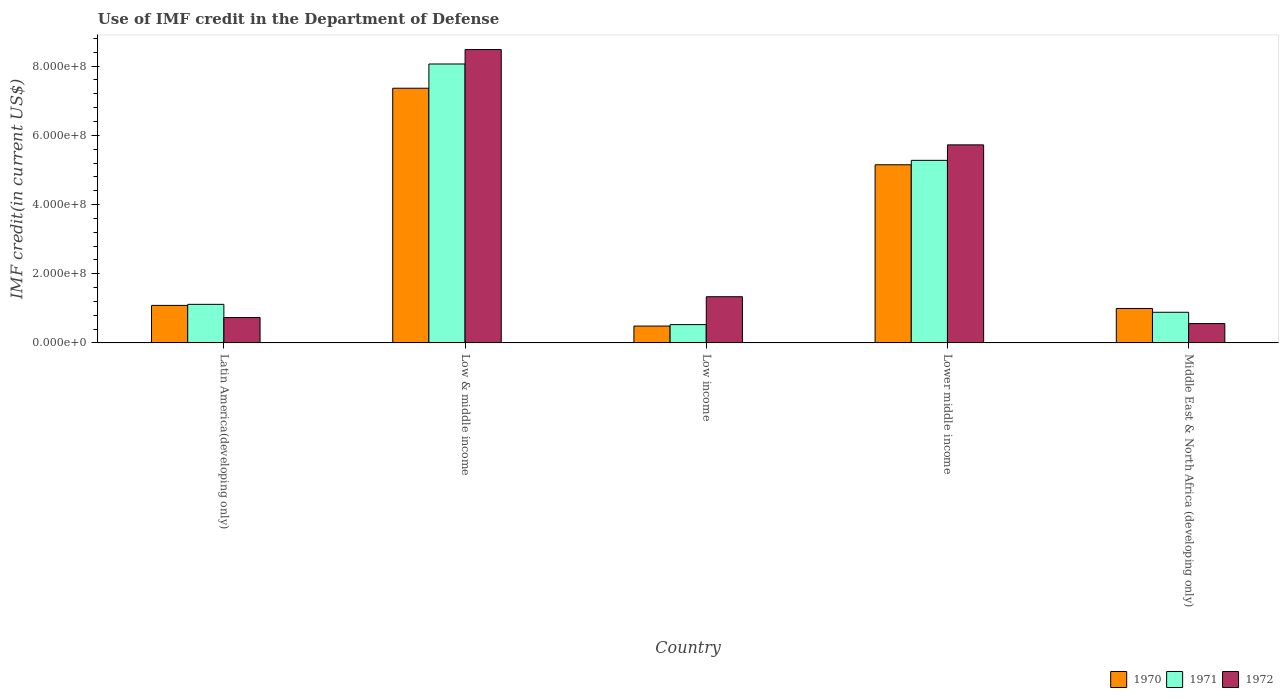How many different coloured bars are there?
Give a very brief answer. 3. How many groups of bars are there?
Provide a succinct answer. 5. Are the number of bars per tick equal to the number of legend labels?
Ensure brevity in your answer.  Yes. How many bars are there on the 4th tick from the right?
Offer a very short reply. 3. In how many cases, is the number of bars for a given country not equal to the number of legend labels?
Your answer should be very brief. 0. What is the IMF credit in the Department of Defense in 1971 in Latin America(developing only)?
Keep it short and to the point. 1.12e+08. Across all countries, what is the maximum IMF credit in the Department of Defense in 1970?
Give a very brief answer. 7.36e+08. Across all countries, what is the minimum IMF credit in the Department of Defense in 1972?
Your answer should be compact. 5.59e+07. In which country was the IMF credit in the Department of Defense in 1972 minimum?
Provide a short and direct response. Middle East & North Africa (developing only). What is the total IMF credit in the Department of Defense in 1970 in the graph?
Keep it short and to the point. 1.51e+09. What is the difference between the IMF credit in the Department of Defense in 1972 in Latin America(developing only) and that in Low income?
Offer a very short reply. -6.01e+07. What is the difference between the IMF credit in the Department of Defense in 1971 in Latin America(developing only) and the IMF credit in the Department of Defense in 1972 in Lower middle income?
Provide a short and direct response. -4.61e+08. What is the average IMF credit in the Department of Defense in 1970 per country?
Provide a short and direct response. 3.02e+08. What is the difference between the IMF credit in the Department of Defense of/in 1972 and IMF credit in the Department of Defense of/in 1971 in Middle East & North Africa (developing only)?
Provide a succinct answer. -3.27e+07. What is the ratio of the IMF credit in the Department of Defense in 1972 in Lower middle income to that in Middle East & North Africa (developing only)?
Give a very brief answer. 10.24. What is the difference between the highest and the second highest IMF credit in the Department of Defense in 1971?
Give a very brief answer. 2.79e+08. What is the difference between the highest and the lowest IMF credit in the Department of Defense in 1970?
Make the answer very short. 6.87e+08. What does the 3rd bar from the left in Middle East & North Africa (developing only) represents?
Your response must be concise. 1972. What does the 1st bar from the right in Lower middle income represents?
Provide a short and direct response. 1972. Is it the case that in every country, the sum of the IMF credit in the Department of Defense in 1972 and IMF credit in the Department of Defense in 1970 is greater than the IMF credit in the Department of Defense in 1971?
Your answer should be compact. Yes. How many countries are there in the graph?
Give a very brief answer. 5. Does the graph contain any zero values?
Provide a succinct answer. No. Does the graph contain grids?
Give a very brief answer. No. How many legend labels are there?
Provide a short and direct response. 3. What is the title of the graph?
Your answer should be very brief. Use of IMF credit in the Department of Defense. Does "1998" appear as one of the legend labels in the graph?
Your response must be concise. No. What is the label or title of the Y-axis?
Your response must be concise. IMF credit(in current US$). What is the IMF credit(in current US$) of 1970 in Latin America(developing only)?
Keep it short and to the point. 1.09e+08. What is the IMF credit(in current US$) in 1971 in Latin America(developing only)?
Provide a succinct answer. 1.12e+08. What is the IMF credit(in current US$) of 1972 in Latin America(developing only)?
Make the answer very short. 7.34e+07. What is the IMF credit(in current US$) of 1970 in Low & middle income?
Offer a very short reply. 7.36e+08. What is the IMF credit(in current US$) in 1971 in Low & middle income?
Offer a very short reply. 8.06e+08. What is the IMF credit(in current US$) in 1972 in Low & middle income?
Make the answer very short. 8.48e+08. What is the IMF credit(in current US$) of 1970 in Low income?
Your answer should be very brief. 4.88e+07. What is the IMF credit(in current US$) in 1971 in Low income?
Make the answer very short. 5.30e+07. What is the IMF credit(in current US$) in 1972 in Low income?
Your answer should be compact. 1.34e+08. What is the IMF credit(in current US$) of 1970 in Lower middle income?
Your answer should be very brief. 5.15e+08. What is the IMF credit(in current US$) in 1971 in Lower middle income?
Offer a terse response. 5.28e+08. What is the IMF credit(in current US$) in 1972 in Lower middle income?
Your answer should be very brief. 5.73e+08. What is the IMF credit(in current US$) in 1970 in Middle East & North Africa (developing only)?
Your answer should be compact. 9.96e+07. What is the IMF credit(in current US$) in 1971 in Middle East & North Africa (developing only)?
Keep it short and to the point. 8.86e+07. What is the IMF credit(in current US$) in 1972 in Middle East & North Africa (developing only)?
Offer a very short reply. 5.59e+07. Across all countries, what is the maximum IMF credit(in current US$) of 1970?
Give a very brief answer. 7.36e+08. Across all countries, what is the maximum IMF credit(in current US$) in 1971?
Your answer should be compact. 8.06e+08. Across all countries, what is the maximum IMF credit(in current US$) of 1972?
Your answer should be compact. 8.48e+08. Across all countries, what is the minimum IMF credit(in current US$) in 1970?
Ensure brevity in your answer.  4.88e+07. Across all countries, what is the minimum IMF credit(in current US$) in 1971?
Your answer should be compact. 5.30e+07. Across all countries, what is the minimum IMF credit(in current US$) in 1972?
Make the answer very short. 5.59e+07. What is the total IMF credit(in current US$) of 1970 in the graph?
Offer a very short reply. 1.51e+09. What is the total IMF credit(in current US$) in 1971 in the graph?
Your answer should be compact. 1.59e+09. What is the total IMF credit(in current US$) in 1972 in the graph?
Offer a terse response. 1.68e+09. What is the difference between the IMF credit(in current US$) in 1970 in Latin America(developing only) and that in Low & middle income?
Your answer should be very brief. -6.28e+08. What is the difference between the IMF credit(in current US$) in 1971 in Latin America(developing only) and that in Low & middle income?
Keep it short and to the point. -6.95e+08. What is the difference between the IMF credit(in current US$) in 1972 in Latin America(developing only) and that in Low & middle income?
Give a very brief answer. -7.75e+08. What is the difference between the IMF credit(in current US$) in 1970 in Latin America(developing only) and that in Low income?
Your answer should be very brief. 5.97e+07. What is the difference between the IMF credit(in current US$) of 1971 in Latin America(developing only) and that in Low income?
Make the answer very short. 5.85e+07. What is the difference between the IMF credit(in current US$) of 1972 in Latin America(developing only) and that in Low income?
Provide a short and direct response. -6.01e+07. What is the difference between the IMF credit(in current US$) of 1970 in Latin America(developing only) and that in Lower middle income?
Make the answer very short. -4.06e+08. What is the difference between the IMF credit(in current US$) in 1971 in Latin America(developing only) and that in Lower middle income?
Make the answer very short. -4.16e+08. What is the difference between the IMF credit(in current US$) in 1972 in Latin America(developing only) and that in Lower middle income?
Provide a short and direct response. -4.99e+08. What is the difference between the IMF credit(in current US$) in 1970 in Latin America(developing only) and that in Middle East & North Africa (developing only)?
Offer a terse response. 8.90e+06. What is the difference between the IMF credit(in current US$) of 1971 in Latin America(developing only) and that in Middle East & North Africa (developing only)?
Offer a very short reply. 2.29e+07. What is the difference between the IMF credit(in current US$) of 1972 in Latin America(developing only) and that in Middle East & North Africa (developing only)?
Make the answer very short. 1.75e+07. What is the difference between the IMF credit(in current US$) of 1970 in Low & middle income and that in Low income?
Your answer should be very brief. 6.87e+08. What is the difference between the IMF credit(in current US$) of 1971 in Low & middle income and that in Low income?
Give a very brief answer. 7.53e+08. What is the difference between the IMF credit(in current US$) in 1972 in Low & middle income and that in Low income?
Keep it short and to the point. 7.14e+08. What is the difference between the IMF credit(in current US$) of 1970 in Low & middle income and that in Lower middle income?
Ensure brevity in your answer.  2.21e+08. What is the difference between the IMF credit(in current US$) in 1971 in Low & middle income and that in Lower middle income?
Keep it short and to the point. 2.79e+08. What is the difference between the IMF credit(in current US$) in 1972 in Low & middle income and that in Lower middle income?
Provide a succinct answer. 2.76e+08. What is the difference between the IMF credit(in current US$) of 1970 in Low & middle income and that in Middle East & North Africa (developing only)?
Provide a short and direct response. 6.37e+08. What is the difference between the IMF credit(in current US$) in 1971 in Low & middle income and that in Middle East & North Africa (developing only)?
Make the answer very short. 7.18e+08. What is the difference between the IMF credit(in current US$) in 1972 in Low & middle income and that in Middle East & North Africa (developing only)?
Provide a short and direct response. 7.92e+08. What is the difference between the IMF credit(in current US$) of 1970 in Low income and that in Lower middle income?
Make the answer very short. -4.66e+08. What is the difference between the IMF credit(in current US$) of 1971 in Low income and that in Lower middle income?
Offer a very short reply. -4.75e+08. What is the difference between the IMF credit(in current US$) of 1972 in Low income and that in Lower middle income?
Your response must be concise. -4.39e+08. What is the difference between the IMF credit(in current US$) of 1970 in Low income and that in Middle East & North Africa (developing only)?
Offer a terse response. -5.08e+07. What is the difference between the IMF credit(in current US$) of 1971 in Low income and that in Middle East & North Africa (developing only)?
Ensure brevity in your answer.  -3.56e+07. What is the difference between the IMF credit(in current US$) of 1972 in Low income and that in Middle East & North Africa (developing only)?
Give a very brief answer. 7.76e+07. What is the difference between the IMF credit(in current US$) of 1970 in Lower middle income and that in Middle East & North Africa (developing only)?
Your answer should be compact. 4.15e+08. What is the difference between the IMF credit(in current US$) of 1971 in Lower middle income and that in Middle East & North Africa (developing only)?
Your response must be concise. 4.39e+08. What is the difference between the IMF credit(in current US$) of 1972 in Lower middle income and that in Middle East & North Africa (developing only)?
Your answer should be compact. 5.17e+08. What is the difference between the IMF credit(in current US$) in 1970 in Latin America(developing only) and the IMF credit(in current US$) in 1971 in Low & middle income?
Give a very brief answer. -6.98e+08. What is the difference between the IMF credit(in current US$) in 1970 in Latin America(developing only) and the IMF credit(in current US$) in 1972 in Low & middle income?
Your answer should be very brief. -7.40e+08. What is the difference between the IMF credit(in current US$) in 1971 in Latin America(developing only) and the IMF credit(in current US$) in 1972 in Low & middle income?
Your answer should be very brief. -7.37e+08. What is the difference between the IMF credit(in current US$) of 1970 in Latin America(developing only) and the IMF credit(in current US$) of 1971 in Low income?
Keep it short and to the point. 5.55e+07. What is the difference between the IMF credit(in current US$) in 1970 in Latin America(developing only) and the IMF credit(in current US$) in 1972 in Low income?
Give a very brief answer. -2.50e+07. What is the difference between the IMF credit(in current US$) of 1971 in Latin America(developing only) and the IMF credit(in current US$) of 1972 in Low income?
Provide a succinct answer. -2.20e+07. What is the difference between the IMF credit(in current US$) in 1970 in Latin America(developing only) and the IMF credit(in current US$) in 1971 in Lower middle income?
Provide a short and direct response. -4.19e+08. What is the difference between the IMF credit(in current US$) in 1970 in Latin America(developing only) and the IMF credit(in current US$) in 1972 in Lower middle income?
Give a very brief answer. -4.64e+08. What is the difference between the IMF credit(in current US$) in 1971 in Latin America(developing only) and the IMF credit(in current US$) in 1972 in Lower middle income?
Your response must be concise. -4.61e+08. What is the difference between the IMF credit(in current US$) in 1970 in Latin America(developing only) and the IMF credit(in current US$) in 1971 in Middle East & North Africa (developing only)?
Your answer should be compact. 1.99e+07. What is the difference between the IMF credit(in current US$) of 1970 in Latin America(developing only) and the IMF credit(in current US$) of 1972 in Middle East & North Africa (developing only)?
Keep it short and to the point. 5.26e+07. What is the difference between the IMF credit(in current US$) of 1971 in Latin America(developing only) and the IMF credit(in current US$) of 1972 in Middle East & North Africa (developing only)?
Provide a short and direct response. 5.56e+07. What is the difference between the IMF credit(in current US$) of 1970 in Low & middle income and the IMF credit(in current US$) of 1971 in Low income?
Keep it short and to the point. 6.83e+08. What is the difference between the IMF credit(in current US$) in 1970 in Low & middle income and the IMF credit(in current US$) in 1972 in Low income?
Provide a succinct answer. 6.03e+08. What is the difference between the IMF credit(in current US$) in 1971 in Low & middle income and the IMF credit(in current US$) in 1972 in Low income?
Offer a very short reply. 6.73e+08. What is the difference between the IMF credit(in current US$) in 1970 in Low & middle income and the IMF credit(in current US$) in 1971 in Lower middle income?
Provide a short and direct response. 2.08e+08. What is the difference between the IMF credit(in current US$) of 1970 in Low & middle income and the IMF credit(in current US$) of 1972 in Lower middle income?
Give a very brief answer. 1.64e+08. What is the difference between the IMF credit(in current US$) in 1971 in Low & middle income and the IMF credit(in current US$) in 1972 in Lower middle income?
Offer a very short reply. 2.34e+08. What is the difference between the IMF credit(in current US$) of 1970 in Low & middle income and the IMF credit(in current US$) of 1971 in Middle East & North Africa (developing only)?
Your answer should be very brief. 6.48e+08. What is the difference between the IMF credit(in current US$) in 1970 in Low & middle income and the IMF credit(in current US$) in 1972 in Middle East & North Africa (developing only)?
Provide a succinct answer. 6.80e+08. What is the difference between the IMF credit(in current US$) in 1971 in Low & middle income and the IMF credit(in current US$) in 1972 in Middle East & North Africa (developing only)?
Your answer should be compact. 7.50e+08. What is the difference between the IMF credit(in current US$) of 1970 in Low income and the IMF credit(in current US$) of 1971 in Lower middle income?
Ensure brevity in your answer.  -4.79e+08. What is the difference between the IMF credit(in current US$) in 1970 in Low income and the IMF credit(in current US$) in 1972 in Lower middle income?
Offer a very short reply. -5.24e+08. What is the difference between the IMF credit(in current US$) in 1971 in Low income and the IMF credit(in current US$) in 1972 in Lower middle income?
Make the answer very short. -5.20e+08. What is the difference between the IMF credit(in current US$) in 1970 in Low income and the IMF credit(in current US$) in 1971 in Middle East & North Africa (developing only)?
Your answer should be compact. -3.98e+07. What is the difference between the IMF credit(in current US$) in 1970 in Low income and the IMF credit(in current US$) in 1972 in Middle East & North Africa (developing only)?
Ensure brevity in your answer.  -7.12e+06. What is the difference between the IMF credit(in current US$) of 1971 in Low income and the IMF credit(in current US$) of 1972 in Middle East & North Africa (developing only)?
Make the answer very short. -2.90e+06. What is the difference between the IMF credit(in current US$) of 1970 in Lower middle income and the IMF credit(in current US$) of 1971 in Middle East & North Africa (developing only)?
Your answer should be compact. 4.26e+08. What is the difference between the IMF credit(in current US$) in 1970 in Lower middle income and the IMF credit(in current US$) in 1972 in Middle East & North Africa (developing only)?
Offer a terse response. 4.59e+08. What is the difference between the IMF credit(in current US$) in 1971 in Lower middle income and the IMF credit(in current US$) in 1972 in Middle East & North Africa (developing only)?
Provide a succinct answer. 4.72e+08. What is the average IMF credit(in current US$) of 1970 per country?
Keep it short and to the point. 3.02e+08. What is the average IMF credit(in current US$) of 1971 per country?
Make the answer very short. 3.17e+08. What is the average IMF credit(in current US$) in 1972 per country?
Your answer should be compact. 3.37e+08. What is the difference between the IMF credit(in current US$) of 1970 and IMF credit(in current US$) of 1971 in Latin America(developing only)?
Offer a terse response. -3.01e+06. What is the difference between the IMF credit(in current US$) in 1970 and IMF credit(in current US$) in 1972 in Latin America(developing only)?
Provide a short and direct response. 3.51e+07. What is the difference between the IMF credit(in current US$) in 1971 and IMF credit(in current US$) in 1972 in Latin America(developing only)?
Your answer should be compact. 3.81e+07. What is the difference between the IMF credit(in current US$) of 1970 and IMF credit(in current US$) of 1971 in Low & middle income?
Provide a succinct answer. -7.00e+07. What is the difference between the IMF credit(in current US$) of 1970 and IMF credit(in current US$) of 1972 in Low & middle income?
Offer a terse response. -1.12e+08. What is the difference between the IMF credit(in current US$) of 1971 and IMF credit(in current US$) of 1972 in Low & middle income?
Offer a terse response. -4.18e+07. What is the difference between the IMF credit(in current US$) of 1970 and IMF credit(in current US$) of 1971 in Low income?
Keep it short and to the point. -4.21e+06. What is the difference between the IMF credit(in current US$) of 1970 and IMF credit(in current US$) of 1972 in Low income?
Your answer should be compact. -8.47e+07. What is the difference between the IMF credit(in current US$) in 1971 and IMF credit(in current US$) in 1972 in Low income?
Make the answer very short. -8.05e+07. What is the difference between the IMF credit(in current US$) in 1970 and IMF credit(in current US$) in 1971 in Lower middle income?
Provide a short and direct response. -1.28e+07. What is the difference between the IMF credit(in current US$) of 1970 and IMF credit(in current US$) of 1972 in Lower middle income?
Ensure brevity in your answer.  -5.76e+07. What is the difference between the IMF credit(in current US$) of 1971 and IMF credit(in current US$) of 1972 in Lower middle income?
Offer a terse response. -4.48e+07. What is the difference between the IMF credit(in current US$) in 1970 and IMF credit(in current US$) in 1971 in Middle East & North Africa (developing only)?
Provide a succinct answer. 1.10e+07. What is the difference between the IMF credit(in current US$) in 1970 and IMF credit(in current US$) in 1972 in Middle East & North Africa (developing only)?
Give a very brief answer. 4.37e+07. What is the difference between the IMF credit(in current US$) in 1971 and IMF credit(in current US$) in 1972 in Middle East & North Africa (developing only)?
Your answer should be compact. 3.27e+07. What is the ratio of the IMF credit(in current US$) in 1970 in Latin America(developing only) to that in Low & middle income?
Your answer should be compact. 0.15. What is the ratio of the IMF credit(in current US$) of 1971 in Latin America(developing only) to that in Low & middle income?
Provide a short and direct response. 0.14. What is the ratio of the IMF credit(in current US$) in 1972 in Latin America(developing only) to that in Low & middle income?
Your response must be concise. 0.09. What is the ratio of the IMF credit(in current US$) in 1970 in Latin America(developing only) to that in Low income?
Your answer should be very brief. 2.22. What is the ratio of the IMF credit(in current US$) in 1971 in Latin America(developing only) to that in Low income?
Your response must be concise. 2.1. What is the ratio of the IMF credit(in current US$) in 1972 in Latin America(developing only) to that in Low income?
Your response must be concise. 0.55. What is the ratio of the IMF credit(in current US$) of 1970 in Latin America(developing only) to that in Lower middle income?
Offer a very short reply. 0.21. What is the ratio of the IMF credit(in current US$) of 1971 in Latin America(developing only) to that in Lower middle income?
Ensure brevity in your answer.  0.21. What is the ratio of the IMF credit(in current US$) of 1972 in Latin America(developing only) to that in Lower middle income?
Your answer should be compact. 0.13. What is the ratio of the IMF credit(in current US$) of 1970 in Latin America(developing only) to that in Middle East & North Africa (developing only)?
Your answer should be very brief. 1.09. What is the ratio of the IMF credit(in current US$) of 1971 in Latin America(developing only) to that in Middle East & North Africa (developing only)?
Ensure brevity in your answer.  1.26. What is the ratio of the IMF credit(in current US$) of 1972 in Latin America(developing only) to that in Middle East & North Africa (developing only)?
Keep it short and to the point. 1.31. What is the ratio of the IMF credit(in current US$) of 1970 in Low & middle income to that in Low income?
Your response must be concise. 15.08. What is the ratio of the IMF credit(in current US$) in 1971 in Low & middle income to that in Low income?
Your answer should be compact. 15.21. What is the ratio of the IMF credit(in current US$) of 1972 in Low & middle income to that in Low income?
Keep it short and to the point. 6.35. What is the ratio of the IMF credit(in current US$) of 1970 in Low & middle income to that in Lower middle income?
Make the answer very short. 1.43. What is the ratio of the IMF credit(in current US$) of 1971 in Low & middle income to that in Lower middle income?
Your answer should be very brief. 1.53. What is the ratio of the IMF credit(in current US$) in 1972 in Low & middle income to that in Lower middle income?
Your answer should be compact. 1.48. What is the ratio of the IMF credit(in current US$) of 1970 in Low & middle income to that in Middle East & North Africa (developing only)?
Give a very brief answer. 7.39. What is the ratio of the IMF credit(in current US$) of 1971 in Low & middle income to that in Middle East & North Africa (developing only)?
Offer a very short reply. 9.1. What is the ratio of the IMF credit(in current US$) of 1972 in Low & middle income to that in Middle East & North Africa (developing only)?
Give a very brief answer. 15.16. What is the ratio of the IMF credit(in current US$) of 1970 in Low income to that in Lower middle income?
Your response must be concise. 0.09. What is the ratio of the IMF credit(in current US$) in 1971 in Low income to that in Lower middle income?
Your response must be concise. 0.1. What is the ratio of the IMF credit(in current US$) of 1972 in Low income to that in Lower middle income?
Your answer should be compact. 0.23. What is the ratio of the IMF credit(in current US$) of 1970 in Low income to that in Middle East & North Africa (developing only)?
Your answer should be compact. 0.49. What is the ratio of the IMF credit(in current US$) of 1971 in Low income to that in Middle East & North Africa (developing only)?
Your response must be concise. 0.6. What is the ratio of the IMF credit(in current US$) of 1972 in Low income to that in Middle East & North Africa (developing only)?
Make the answer very short. 2.39. What is the ratio of the IMF credit(in current US$) in 1970 in Lower middle income to that in Middle East & North Africa (developing only)?
Your answer should be very brief. 5.17. What is the ratio of the IMF credit(in current US$) in 1971 in Lower middle income to that in Middle East & North Africa (developing only)?
Ensure brevity in your answer.  5.95. What is the ratio of the IMF credit(in current US$) of 1972 in Lower middle income to that in Middle East & North Africa (developing only)?
Make the answer very short. 10.24. What is the difference between the highest and the second highest IMF credit(in current US$) of 1970?
Your answer should be very brief. 2.21e+08. What is the difference between the highest and the second highest IMF credit(in current US$) in 1971?
Offer a terse response. 2.79e+08. What is the difference between the highest and the second highest IMF credit(in current US$) of 1972?
Provide a succinct answer. 2.76e+08. What is the difference between the highest and the lowest IMF credit(in current US$) of 1970?
Keep it short and to the point. 6.87e+08. What is the difference between the highest and the lowest IMF credit(in current US$) of 1971?
Ensure brevity in your answer.  7.53e+08. What is the difference between the highest and the lowest IMF credit(in current US$) in 1972?
Your response must be concise. 7.92e+08. 